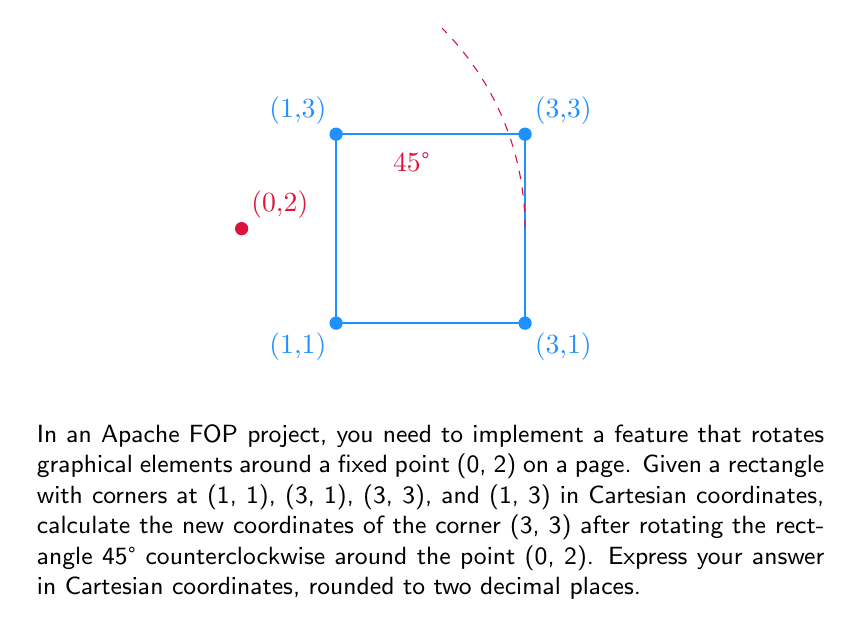Teach me how to tackle this problem. To solve this problem, we'll use polar coordinates and follow these steps:

1) First, we need to convert the point (3, 3) to polar coordinates with respect to the center of rotation (0, 2):
   
   $x' = 3 - 0 = 3$
   $y' = 3 - 2 = 1$
   
   $r = \sqrt{x'^2 + y'^2} = \sqrt{3^2 + 1^2} = \sqrt{10}$
   
   $\theta = \arctan(\frac{y'}{x'}) = \arctan(\frac{1}{3})$

2) Now we add 45° (or $\frac{\pi}{4}$ radians) to $\theta$:
   
   $\theta_{new} = \arctan(\frac{1}{3}) + \frac{\pi}{4}$

3) We convert back to Cartesian coordinates:
   
   $x_{new} = r \cos(\theta_{new}) + 0$
   $y_{new} = r \sin(\theta_{new}) + 2$

4) Substituting the values:
   
   $x_{new} = \sqrt{10} \cos(\arctan(\frac{1}{3}) + \frac{\pi}{4})$
   $y_{new} = \sqrt{10} \sin(\arctan(\frac{1}{3}) + \frac{\pi}{4}) + 2$

5) Calculating these values (you would use a calculator or programming language for precision):
   
   $x_{new} \approx 1.17$
   $y_{new} \approx 4.24$

6) Rounding to two decimal places:
   
   $x_{new} = 1.17$
   $y_{new} = 4.24$
Answer: (1.17, 4.24) 